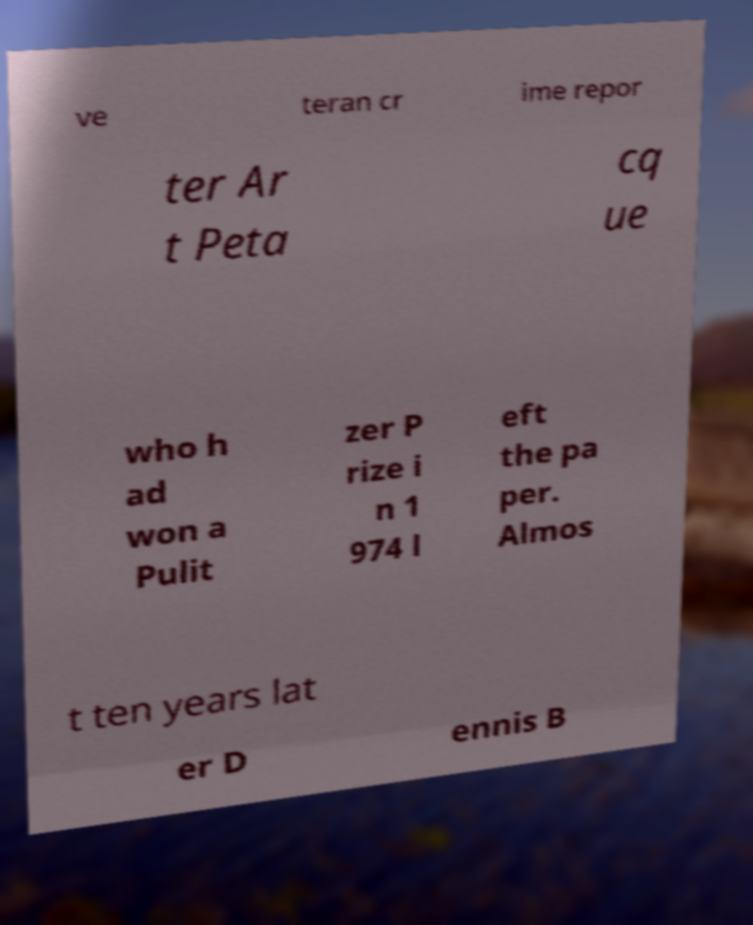For documentation purposes, I need the text within this image transcribed. Could you provide that? ve teran cr ime repor ter Ar t Peta cq ue who h ad won a Pulit zer P rize i n 1 974 l eft the pa per. Almos t ten years lat er D ennis B 